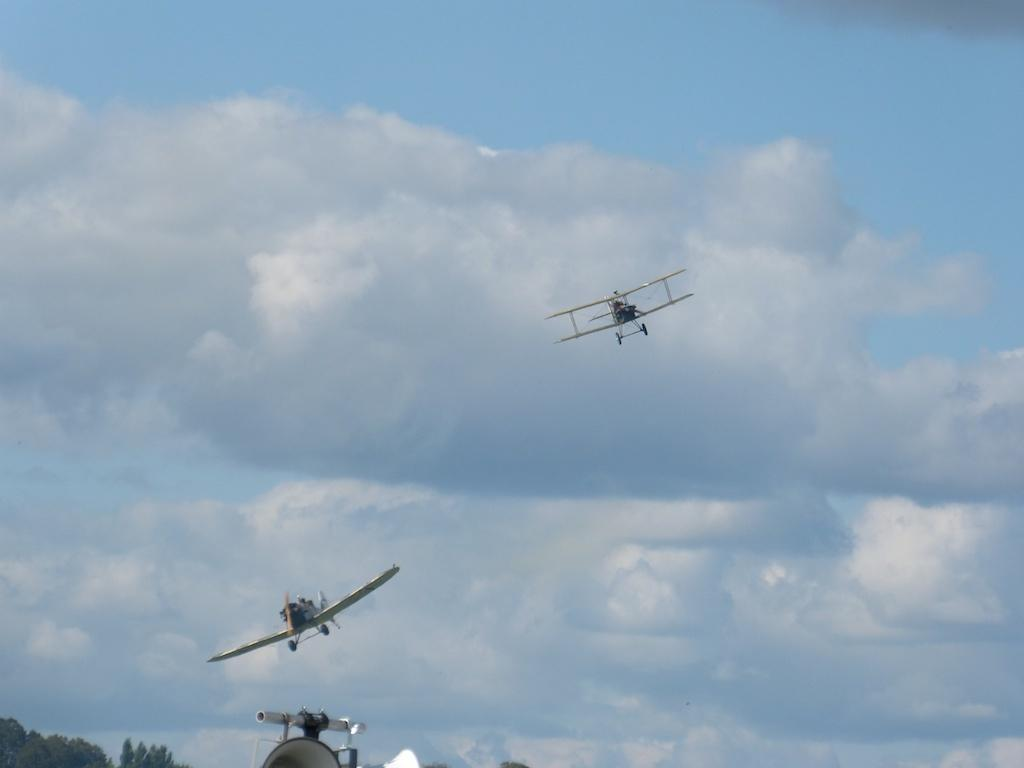What is happening in the sky in the image? There are airplanes flying in the sky in the image. What type of natural scenery can be seen in the image? There are trees visible in the image. Can you describe the object at the bottom of the image? Unfortunately, the facts provided do not give any information about the object at the bottom of the image. Is there a stamp on the trees in the image? There is no mention of a stamp in the image, and the facts provided do not suggest its presence. 